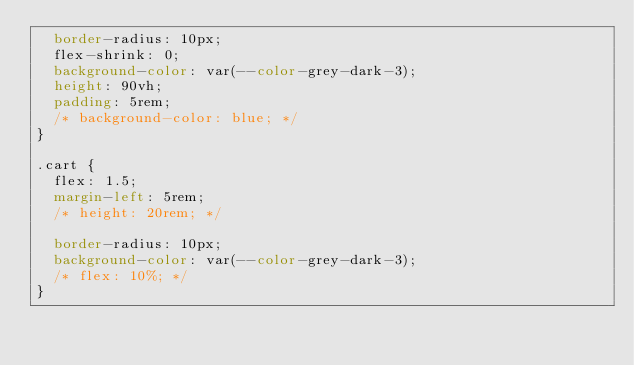<code> <loc_0><loc_0><loc_500><loc_500><_CSS_>  border-radius: 10px;
  flex-shrink: 0;
  background-color: var(--color-grey-dark-3);
  height: 90vh;
  padding: 5rem;
  /* background-color: blue; */
}

.cart {
  flex: 1.5;
  margin-left: 5rem;
  /* height: 20rem; */

  border-radius: 10px;
  background-color: var(--color-grey-dark-3);
  /* flex: 10%; */
}
</code> 